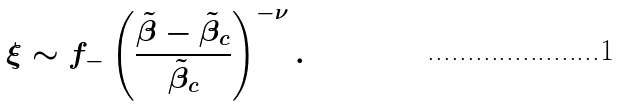Convert formula to latex. <formula><loc_0><loc_0><loc_500><loc_500>\xi \sim f _ { - } \left ( \frac { \tilde { \beta } - \tilde { \beta } _ { c } } { \tilde { \beta } _ { c } } \right ) ^ { - \nu } .</formula> 